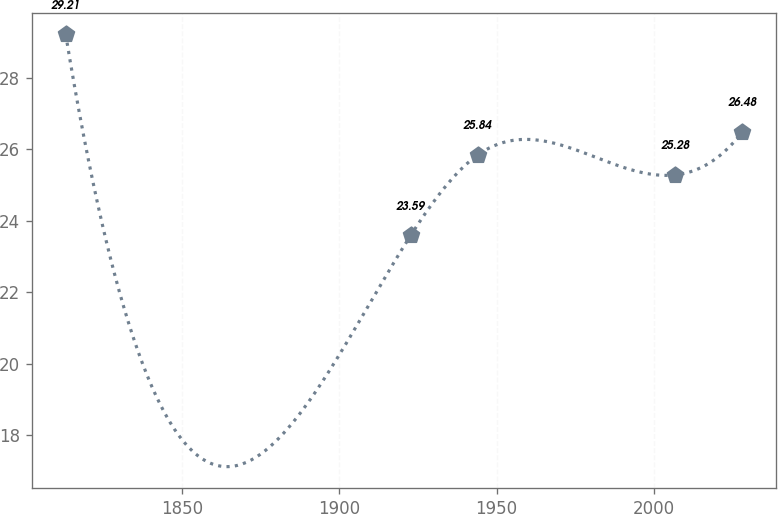Convert chart to OTSL. <chart><loc_0><loc_0><loc_500><loc_500><line_chart><ecel><fcel>Unnamed: 1<nl><fcel>1812.94<fcel>29.21<nl><fcel>1922.69<fcel>23.59<nl><fcel>1944.04<fcel>25.84<nl><fcel>2006.82<fcel>25.28<nl><fcel>2028.17<fcel>26.48<nl></chart> 